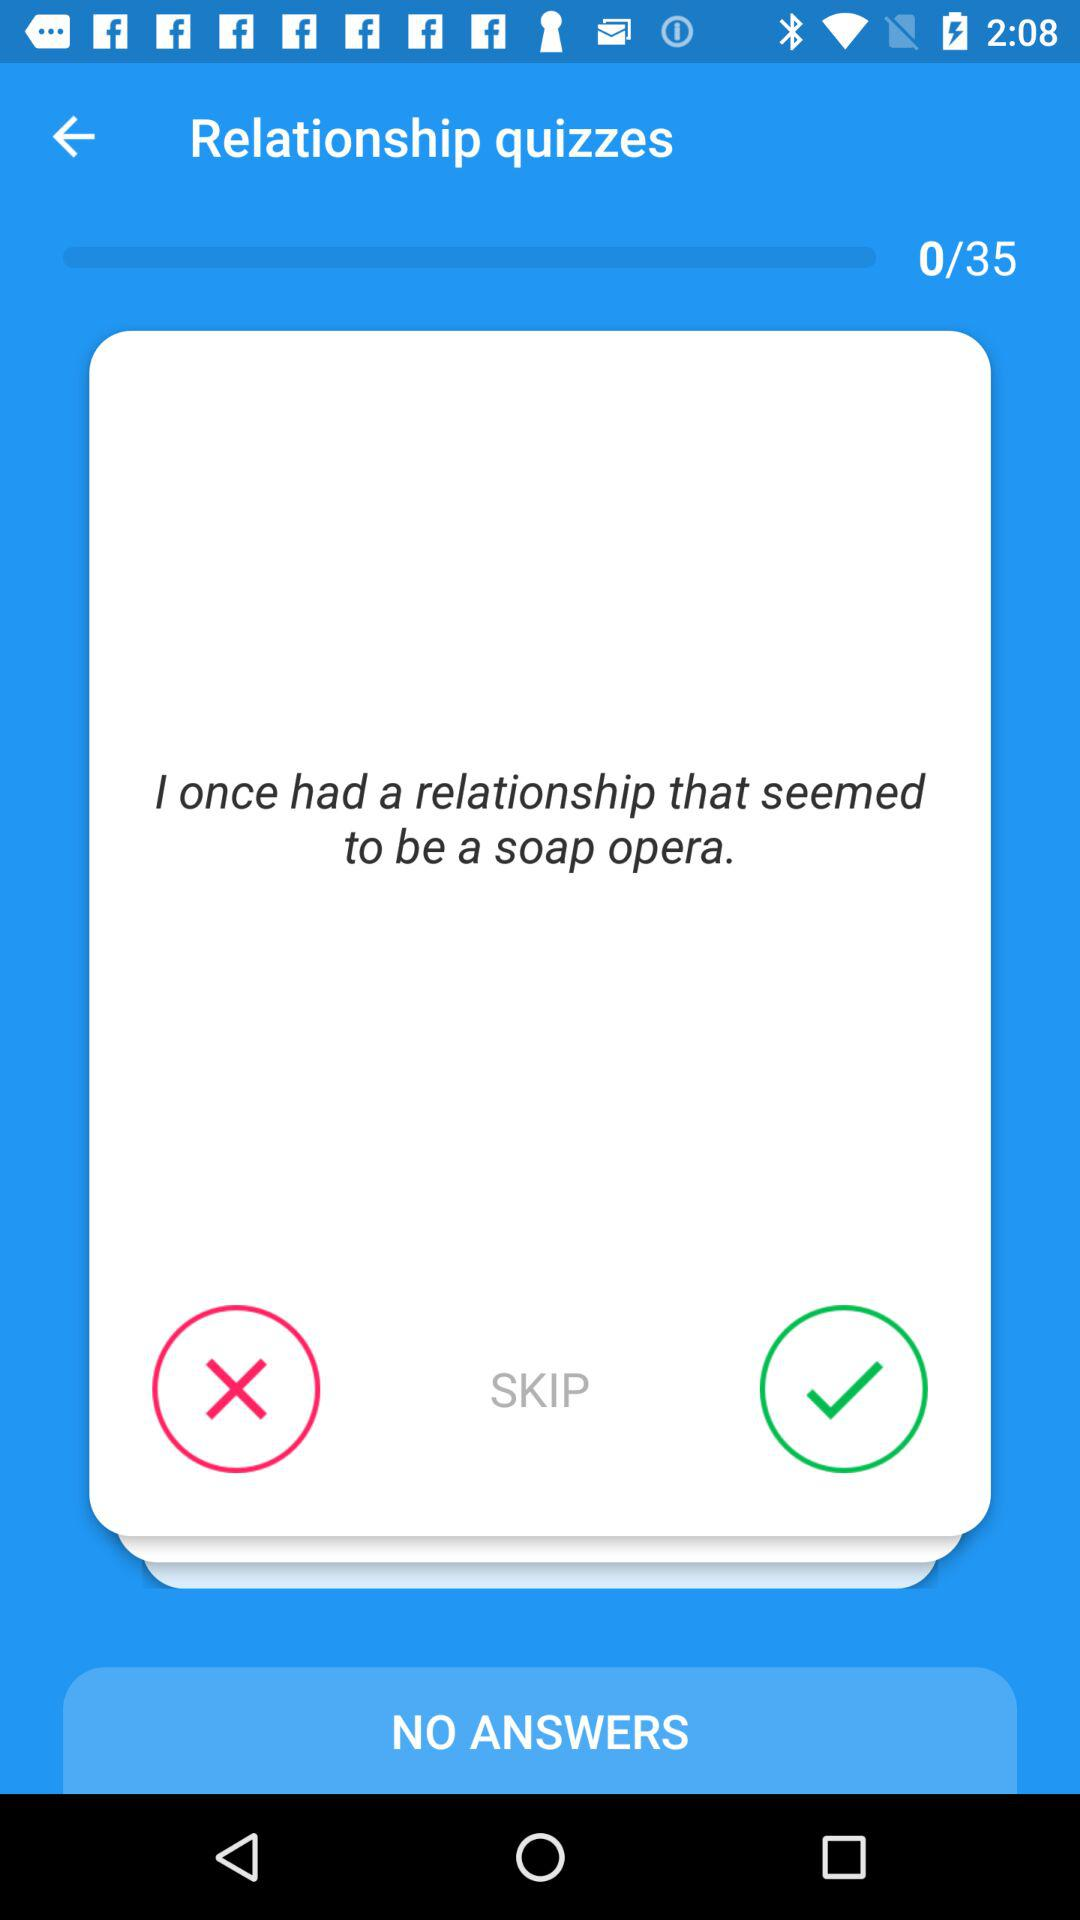How many more answers do I need to complete the quiz?
Answer the question using a single word or phrase. 35 